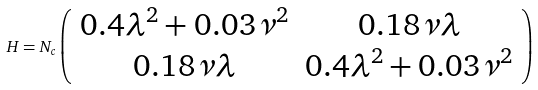<formula> <loc_0><loc_0><loc_500><loc_500>H = N _ { c } \left ( \begin{array} { c c } 0 . 4 \lambda ^ { 2 } + 0 . 0 3 \nu ^ { 2 } & 0 . 1 8 \nu \lambda \\ 0 . 1 8 \nu \lambda & 0 . 4 \lambda ^ { 2 } + 0 . 0 3 \nu ^ { 2 } \end{array} \right )</formula> 